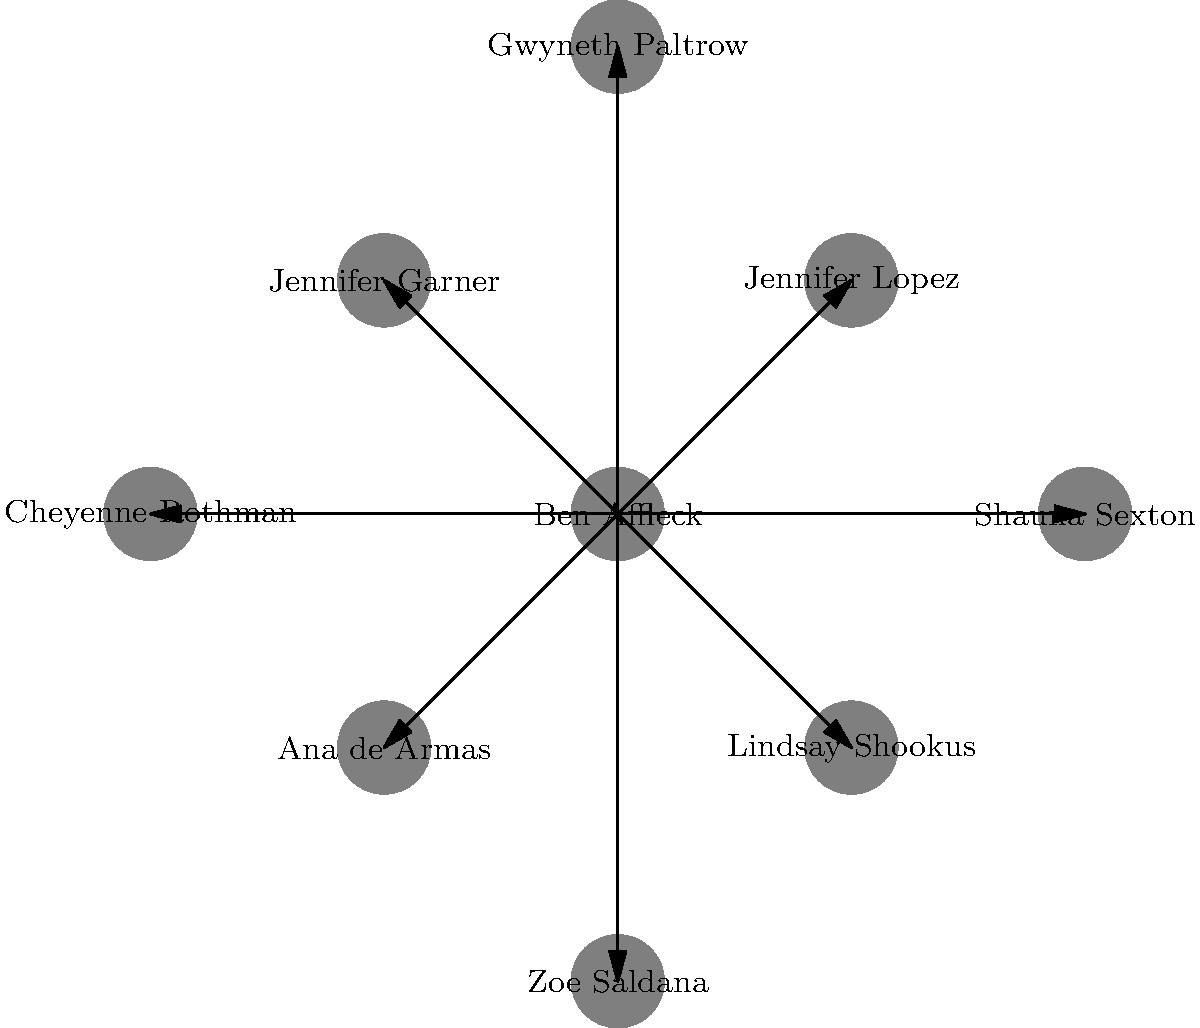In this network diagram of Ben Affleck's rumored romantic relationships, which celebrity is positioned directly opposite to Jennifer Lopez? To answer this question, let's analyze the network diagram step-by-step:

1. Ben Affleck is positioned at the center of the diagram.
2. The celebrities are arranged in a circular pattern around Ben Affleck.
3. Jennifer Lopez is positioned at the top right of the diagram (1,1).
4. To find the celebrity directly opposite Jennifer Lopez, we need to look at the bottom left of the diagram (-1,-1).
5. The celebrity positioned at (-1,-1) is Ana de Armas.

Therefore, Ana de Armas is positioned directly opposite to Jennifer Lopez in this network diagram of Ben Affleck's rumored romantic relationships.
Answer: Ana de Armas 